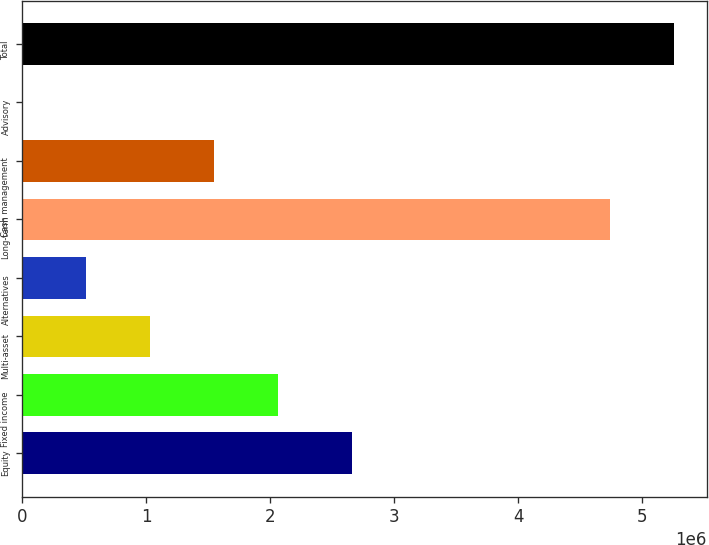Convert chart to OTSL. <chart><loc_0><loc_0><loc_500><loc_500><bar_chart><fcel>Equity<fcel>Fixed income<fcel>Multi-asset<fcel>Alternatives<fcel>Long-term<fcel>Cash management<fcel>Advisory<fcel>Total<nl><fcel>2.65718e+06<fcel>2.06081e+06<fcel>1.0318e+06<fcel>517289<fcel>4.74149e+06<fcel>1.5463e+06<fcel>2782<fcel>5.25599e+06<nl></chart> 